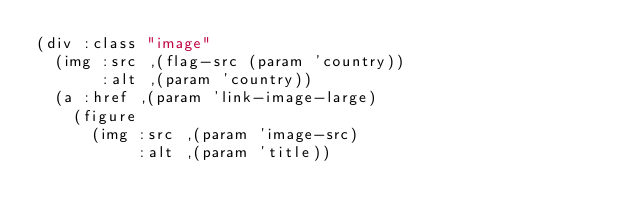Convert code to text. <code><loc_0><loc_0><loc_500><loc_500><_Lisp_>(div :class "image"
  (img :src ,(flag-src (param 'country))
       :alt ,(param 'country))
  (a :href ,(param 'link-image-large)
    (figure
      (img :src ,(param 'image-src)
           :alt ,(param 'title))</code> 